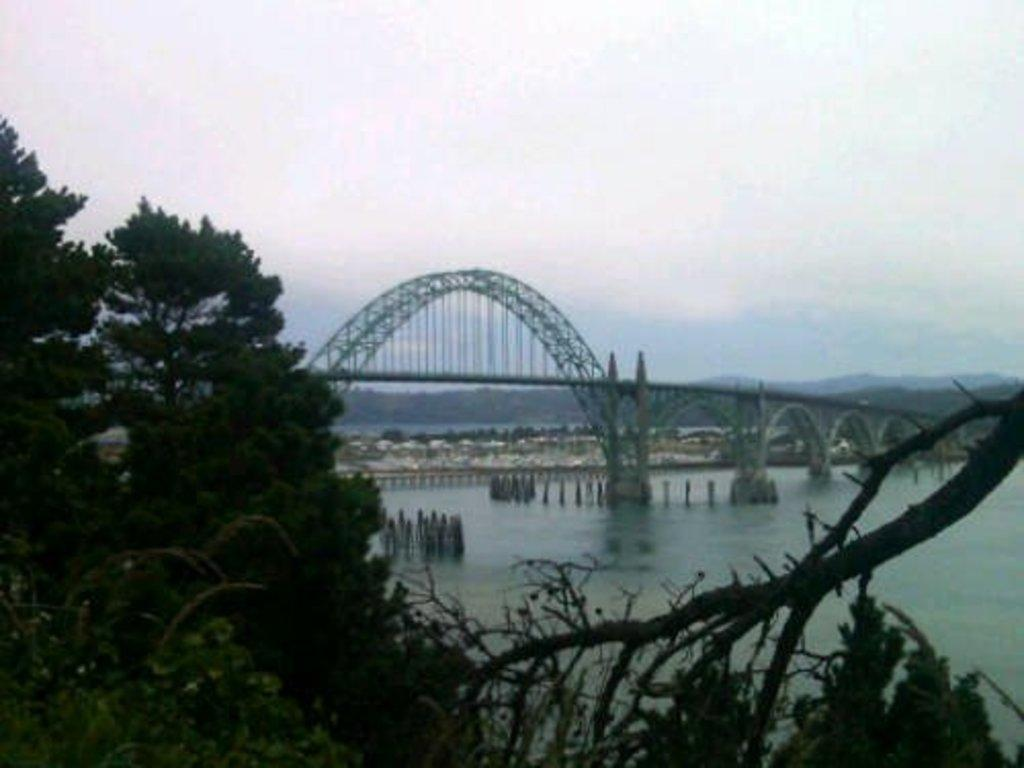What type of natural feature is present in the image? There is a river in the image. What structure is built over the river? There is a bridge above the river. What type of vegetation can be seen in the image? There are trees in the image. What is visible in the background of the image? The sky is visible in the background of the image. How does the river compare to other rivers in terms of health? The image does not provide any information about the health of the river, so it cannot be compared to other rivers. 